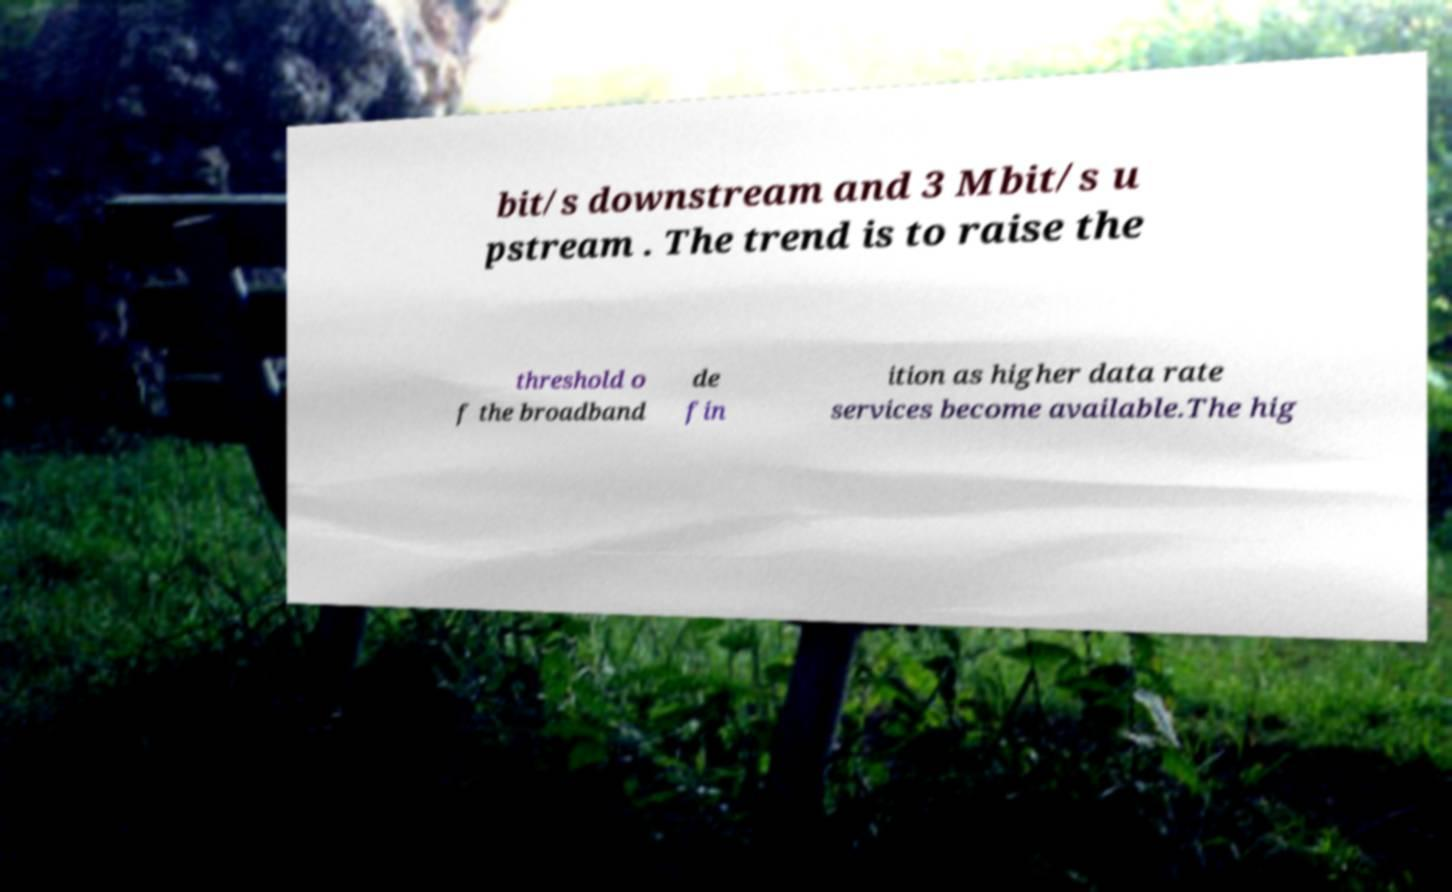Please read and relay the text visible in this image. What does it say? bit/s downstream and 3 Mbit/s u pstream . The trend is to raise the threshold o f the broadband de fin ition as higher data rate services become available.The hig 